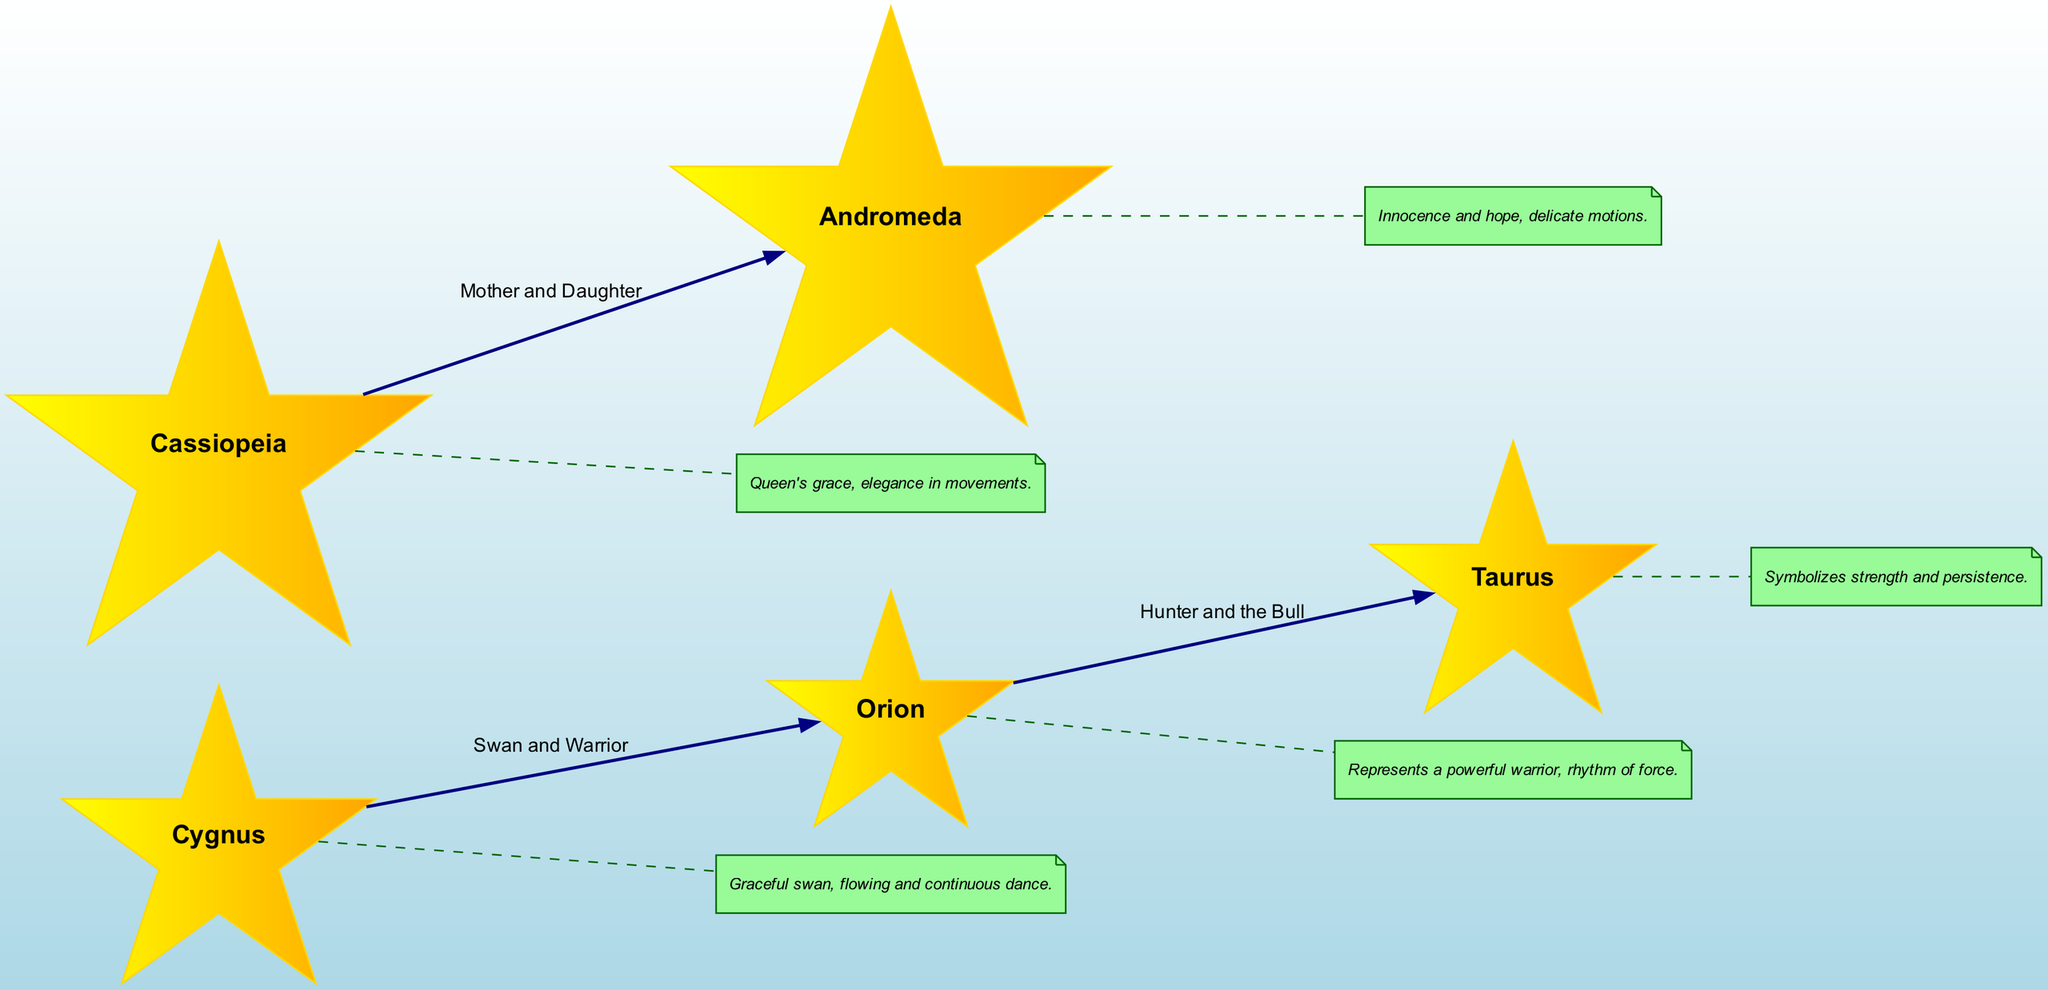What are the names of the major nodes in the diagram? The diagram contains five major nodes: Orion, Taurus, Cassiopeia, Andromeda, and Cygnus. These names are shown clearly at their respective positions in the diagram.
Answer: Orion, Taurus, Cassiopeia, Andromeda, Cygnus How many edges are present in the diagram? There are three edges connecting the nodes in the diagram. Each edge represents a relationship between two constellations outlined in the edges section of the data.
Answer: 3 What does Orion represent in the diagram? Orion is labeled as representing a powerful warrior, which is indicated in the annotations associated with this node in the diagram.
Answer: A powerful warrior What relationship is depicted between Cassiopeia and Andromeda? The relationship shown is labeled as "Mother and Daughter," connecting the two constellations. This is confirmed by the edge connecting these nodes in the edges section.
Answer: Mother and Daughter Which node symbolizes strength and persistence? The node representing strength and persistence is Taurus, as indicated in the annotations section where each constellation's symbolism is detailed.
Answer: Taurus What type of dance movement is related to Cygnus? Cygnus is associated with a graceful and flowing dance that is continuous, as described in the annotation for this constellation in the diagram.
Answer: Flowing and continuous dance How do the stories of Orion and Taurus connect? The connection between Orion and Taurus is represented by the edge labeled "Hunter and the Bull," indicating a narrative about a hunter's relationship with the bull in mythology.
Answer: Hunter and the Bull What symbolizes innocence and hope in the diagram? Andromeda symbolizes innocence and hope according to the annotation provided for this node.
Answer: Innocence and hope 